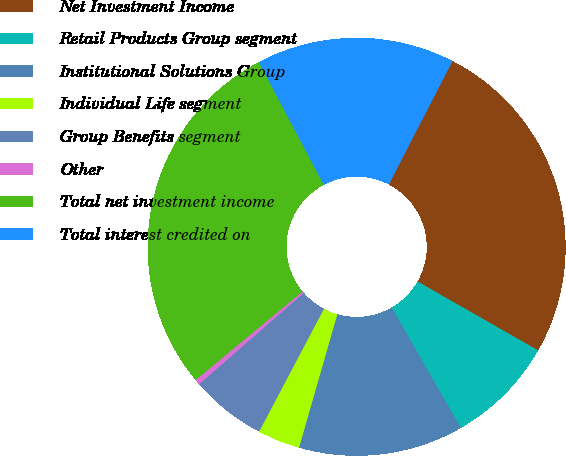Convert chart to OTSL. <chart><loc_0><loc_0><loc_500><loc_500><pie_chart><fcel>Net Investment Income<fcel>Retail Products Group segment<fcel>Institutional Solutions Group<fcel>Individual Life segment<fcel>Group Benefits segment<fcel>Other<fcel>Total net investment income<fcel>Total interest credited on<nl><fcel>25.68%<fcel>8.43%<fcel>12.76%<fcel>3.28%<fcel>5.86%<fcel>0.41%<fcel>28.25%<fcel>15.33%<nl></chart> 